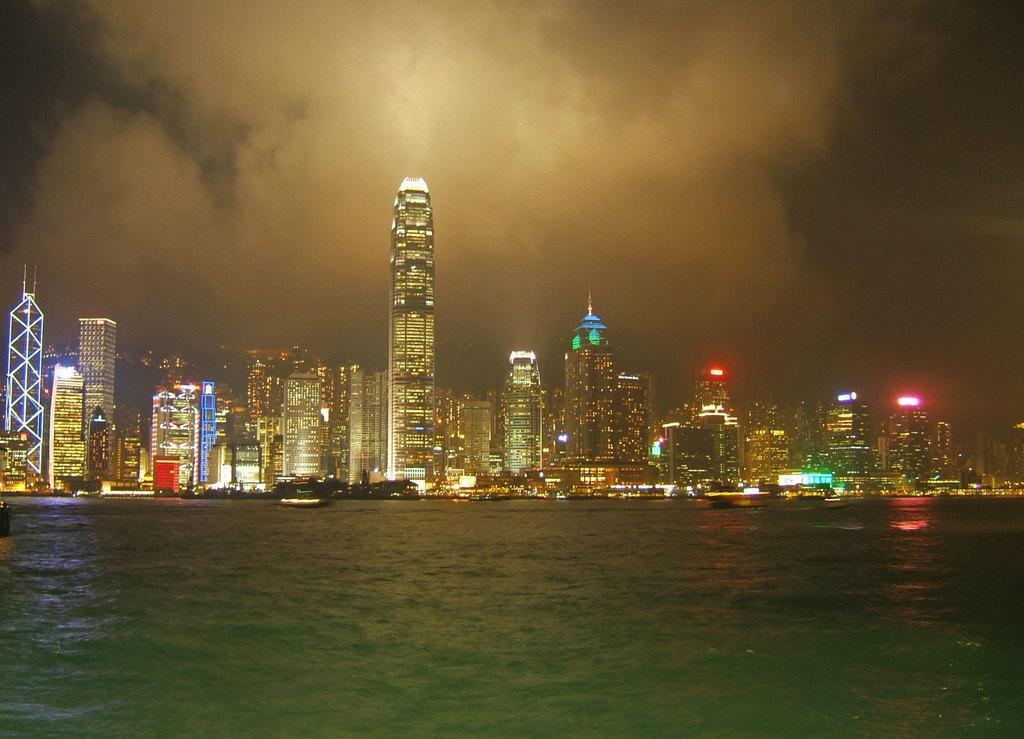In one or two sentences, can you explain what this image depicts? In this image in the center there some buildings, skyscrapers, lights and trees. At the bottom there is a river, and at the top there is sky. 